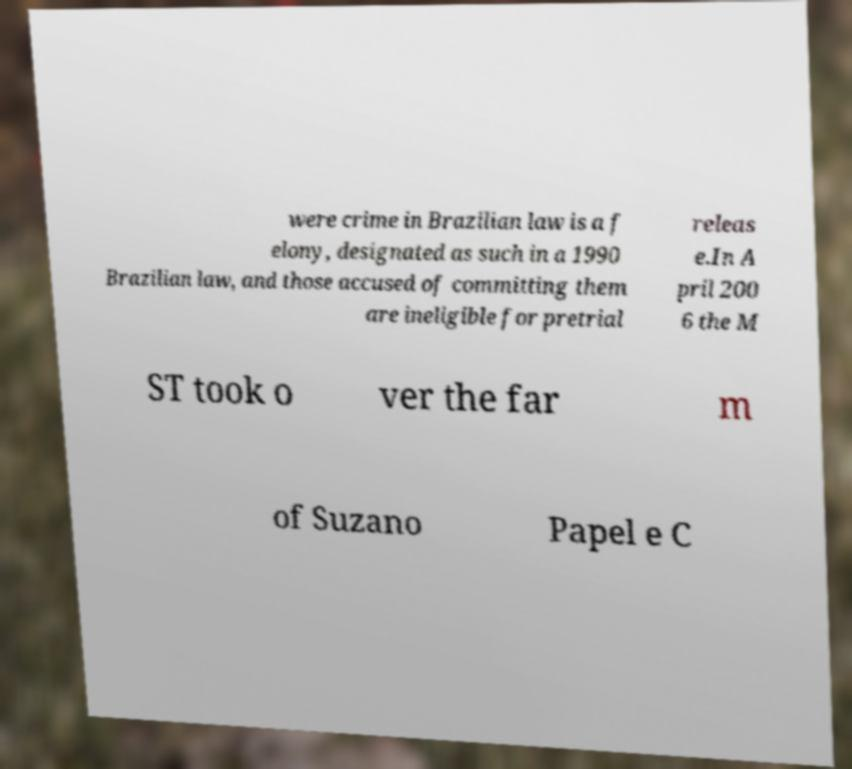What messages or text are displayed in this image? I need them in a readable, typed format. were crime in Brazilian law is a f elony, designated as such in a 1990 Brazilian law, and those accused of committing them are ineligible for pretrial releas e.In A pril 200 6 the M ST took o ver the far m of Suzano Papel e C 